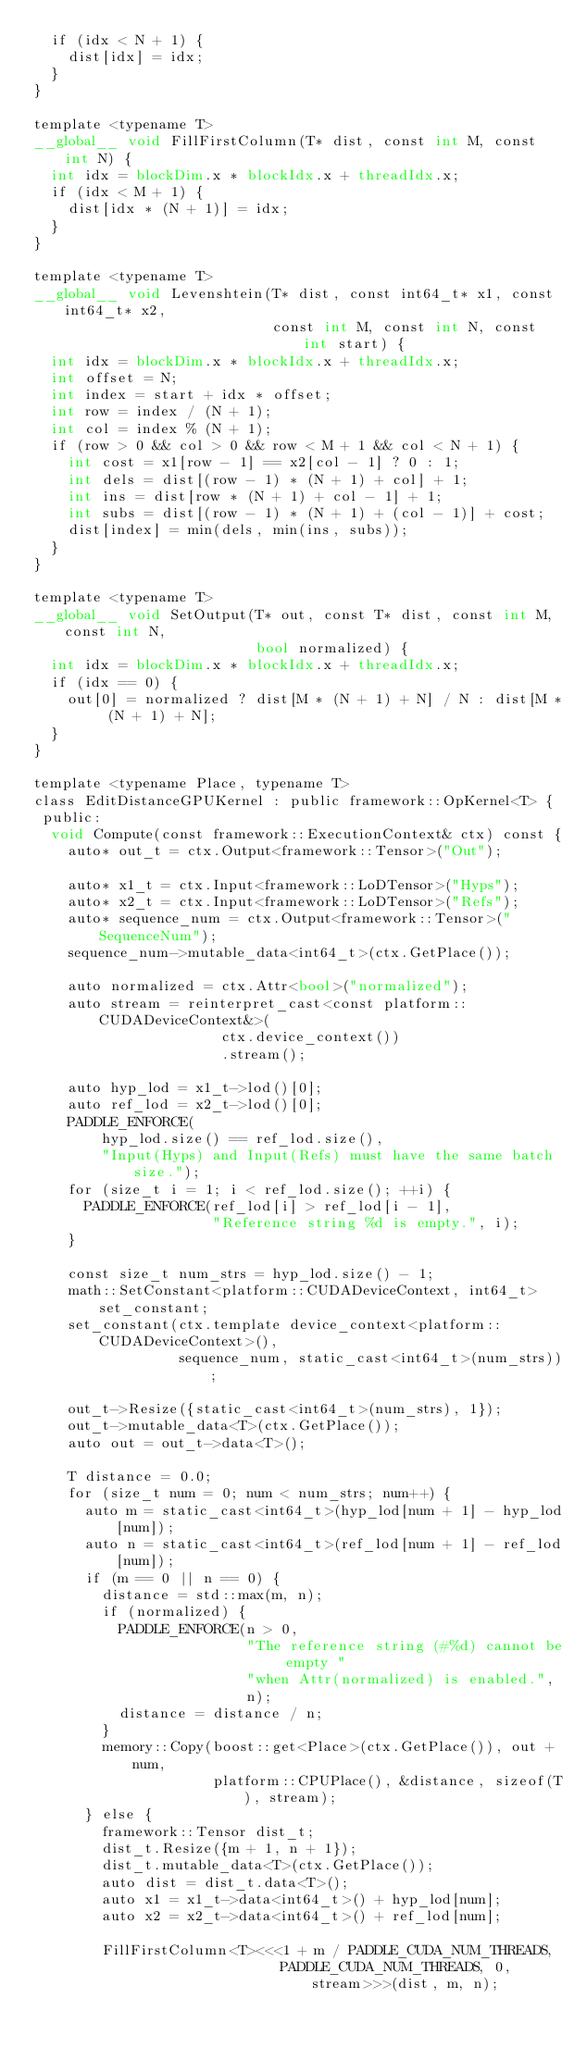<code> <loc_0><loc_0><loc_500><loc_500><_Cuda_>  if (idx < N + 1) {
    dist[idx] = idx;
  }
}

template <typename T>
__global__ void FillFirstColumn(T* dist, const int M, const int N) {
  int idx = blockDim.x * blockIdx.x + threadIdx.x;
  if (idx < M + 1) {
    dist[idx * (N + 1)] = idx;
  }
}

template <typename T>
__global__ void Levenshtein(T* dist, const int64_t* x1, const int64_t* x2,
                            const int M, const int N, const int start) {
  int idx = blockDim.x * blockIdx.x + threadIdx.x;
  int offset = N;
  int index = start + idx * offset;
  int row = index / (N + 1);
  int col = index % (N + 1);
  if (row > 0 && col > 0 && row < M + 1 && col < N + 1) {
    int cost = x1[row - 1] == x2[col - 1] ? 0 : 1;
    int dels = dist[(row - 1) * (N + 1) + col] + 1;
    int ins = dist[row * (N + 1) + col - 1] + 1;
    int subs = dist[(row - 1) * (N + 1) + (col - 1)] + cost;
    dist[index] = min(dels, min(ins, subs));
  }
}

template <typename T>
__global__ void SetOutput(T* out, const T* dist, const int M, const int N,
                          bool normalized) {
  int idx = blockDim.x * blockIdx.x + threadIdx.x;
  if (idx == 0) {
    out[0] = normalized ? dist[M * (N + 1) + N] / N : dist[M * (N + 1) + N];
  }
}

template <typename Place, typename T>
class EditDistanceGPUKernel : public framework::OpKernel<T> {
 public:
  void Compute(const framework::ExecutionContext& ctx) const {
    auto* out_t = ctx.Output<framework::Tensor>("Out");

    auto* x1_t = ctx.Input<framework::LoDTensor>("Hyps");
    auto* x2_t = ctx.Input<framework::LoDTensor>("Refs");
    auto* sequence_num = ctx.Output<framework::Tensor>("SequenceNum");
    sequence_num->mutable_data<int64_t>(ctx.GetPlace());

    auto normalized = ctx.Attr<bool>("normalized");
    auto stream = reinterpret_cast<const platform::CUDADeviceContext&>(
                      ctx.device_context())
                      .stream();

    auto hyp_lod = x1_t->lod()[0];
    auto ref_lod = x2_t->lod()[0];
    PADDLE_ENFORCE(
        hyp_lod.size() == ref_lod.size(),
        "Input(Hyps) and Input(Refs) must have the same batch size.");
    for (size_t i = 1; i < ref_lod.size(); ++i) {
      PADDLE_ENFORCE(ref_lod[i] > ref_lod[i - 1],
                     "Reference string %d is empty.", i);
    }

    const size_t num_strs = hyp_lod.size() - 1;
    math::SetConstant<platform::CUDADeviceContext, int64_t> set_constant;
    set_constant(ctx.template device_context<platform::CUDADeviceContext>(),
                 sequence_num, static_cast<int64_t>(num_strs));

    out_t->Resize({static_cast<int64_t>(num_strs), 1});
    out_t->mutable_data<T>(ctx.GetPlace());
    auto out = out_t->data<T>();

    T distance = 0.0;
    for (size_t num = 0; num < num_strs; num++) {
      auto m = static_cast<int64_t>(hyp_lod[num + 1] - hyp_lod[num]);
      auto n = static_cast<int64_t>(ref_lod[num + 1] - ref_lod[num]);
      if (m == 0 || n == 0) {
        distance = std::max(m, n);
        if (normalized) {
          PADDLE_ENFORCE(n > 0,
                         "The reference string (#%d) cannot be empty "
                         "when Attr(normalized) is enabled.",
                         n);
          distance = distance / n;
        }
        memory::Copy(boost::get<Place>(ctx.GetPlace()), out + num,
                     platform::CPUPlace(), &distance, sizeof(T), stream);
      } else {
        framework::Tensor dist_t;
        dist_t.Resize({m + 1, n + 1});
        dist_t.mutable_data<T>(ctx.GetPlace());
        auto dist = dist_t.data<T>();
        auto x1 = x1_t->data<int64_t>() + hyp_lod[num];
        auto x2 = x2_t->data<int64_t>() + ref_lod[num];

        FillFirstColumn<T><<<1 + m / PADDLE_CUDA_NUM_THREADS,
                             PADDLE_CUDA_NUM_THREADS, 0, stream>>>(dist, m, n);
</code> 